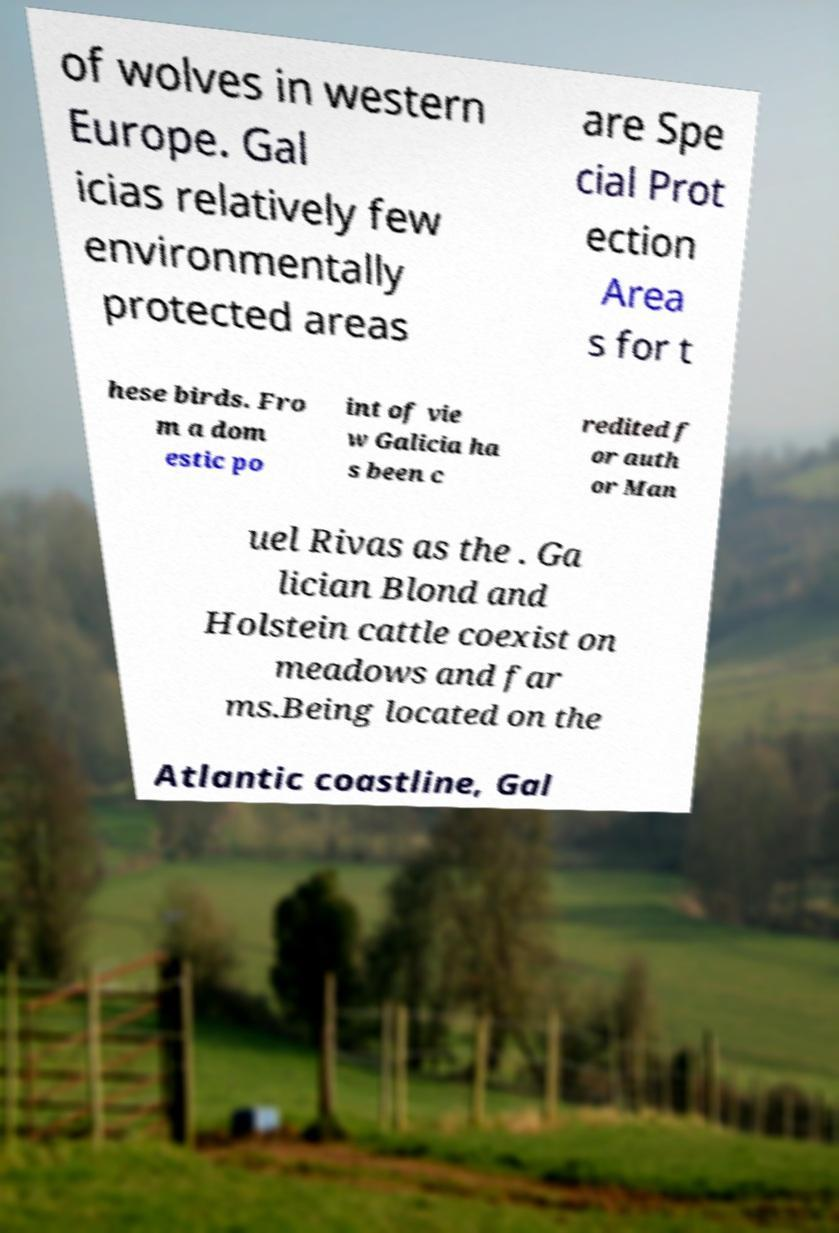There's text embedded in this image that I need extracted. Can you transcribe it verbatim? of wolves in western Europe. Gal icias relatively few environmentally protected areas are Spe cial Prot ection Area s for t hese birds. Fro m a dom estic po int of vie w Galicia ha s been c redited f or auth or Man uel Rivas as the . Ga lician Blond and Holstein cattle coexist on meadows and far ms.Being located on the Atlantic coastline, Gal 